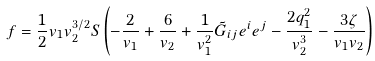Convert formula to latex. <formula><loc_0><loc_0><loc_500><loc_500>f = \frac { 1 } { 2 } v _ { 1 } v _ { 2 } ^ { 3 / 2 } S \left ( - \frac { 2 } { v _ { 1 } } + \frac { 6 } { v _ { 2 } } + \frac { 1 } { v _ { 1 } ^ { 2 } } \tilde { G } _ { i j } e ^ { i } e ^ { j } - \frac { 2 q _ { 1 } ^ { 2 } } { v _ { 2 } ^ { 3 } } - \frac { 3 \zeta } { v _ { 1 } v _ { 2 } } \right )</formula> 